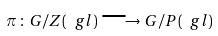Convert formula to latex. <formula><loc_0><loc_0><loc_500><loc_500>\pi \, \colon \, G / Z ( \ g l ) \, \longrightarrow \, G / P ( \ g l )</formula> 